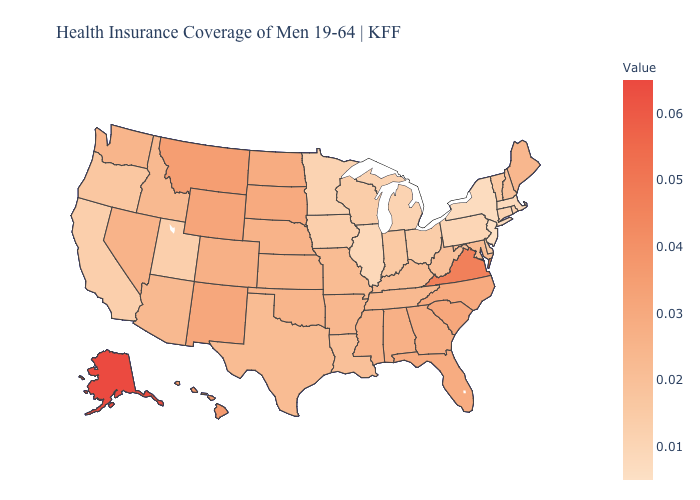Does Delaware have the lowest value in the South?
Quick response, please. Yes. Among the states that border Wisconsin , which have the lowest value?
Answer briefly. Illinois. Does Mississippi have the highest value in the South?
Short answer required. No. Which states have the lowest value in the South?
Keep it brief. Delaware. Which states have the lowest value in the USA?
Concise answer only. New Jersey. Among the states that border Arkansas , does Texas have the lowest value?
Give a very brief answer. No. Does Delaware have a lower value than New Jersey?
Concise answer only. No. Does New Jersey have the lowest value in the Northeast?
Write a very short answer. Yes. Does Alaska have the highest value in the USA?
Answer briefly. Yes. Is the legend a continuous bar?
Write a very short answer. Yes. 